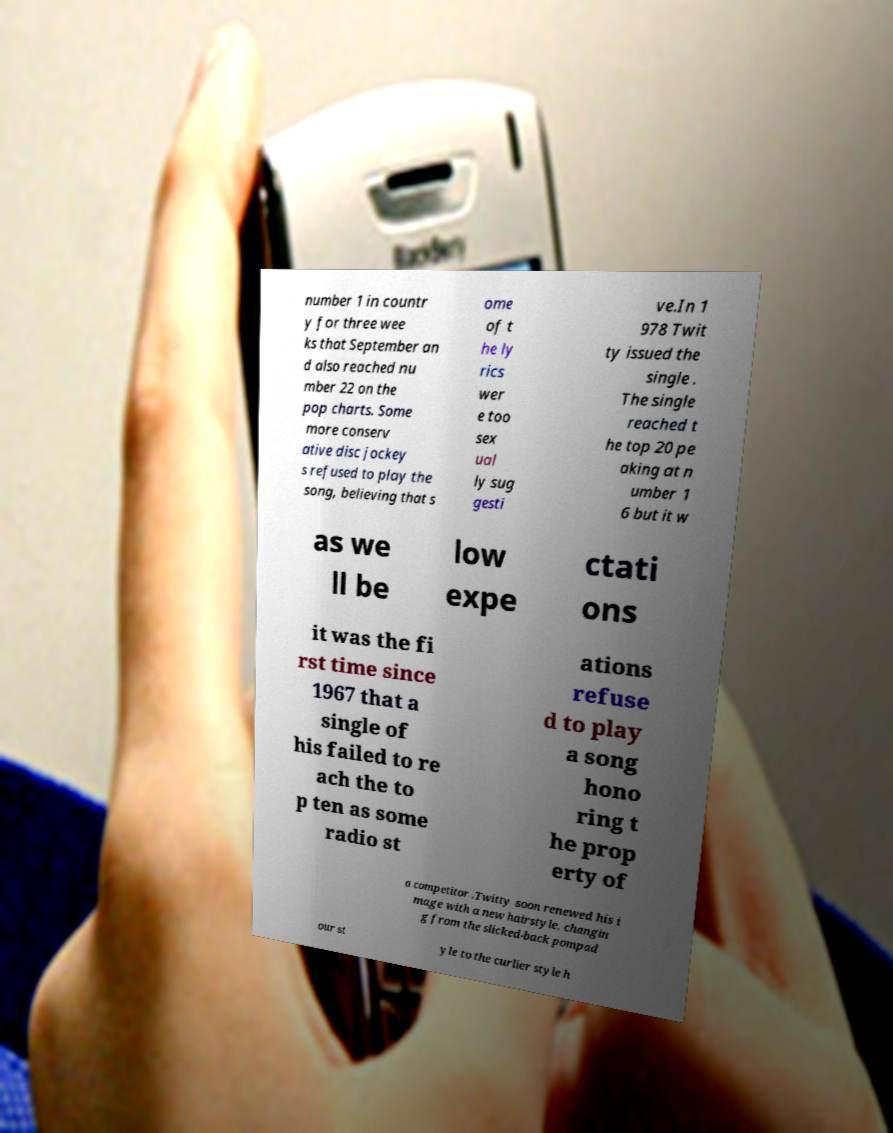For documentation purposes, I need the text within this image transcribed. Could you provide that? number 1 in countr y for three wee ks that September an d also reached nu mber 22 on the pop charts. Some more conserv ative disc jockey s refused to play the song, believing that s ome of t he ly rics wer e too sex ual ly sug gesti ve.In 1 978 Twit ty issued the single . The single reached t he top 20 pe aking at n umber 1 6 but it w as we ll be low expe ctati ons it was the fi rst time since 1967 that a single of his failed to re ach the to p ten as some radio st ations refuse d to play a song hono ring t he prop erty of a competitor .Twitty soon renewed his i mage with a new hairstyle, changin g from the slicked-back pompad our st yle to the curlier style h 